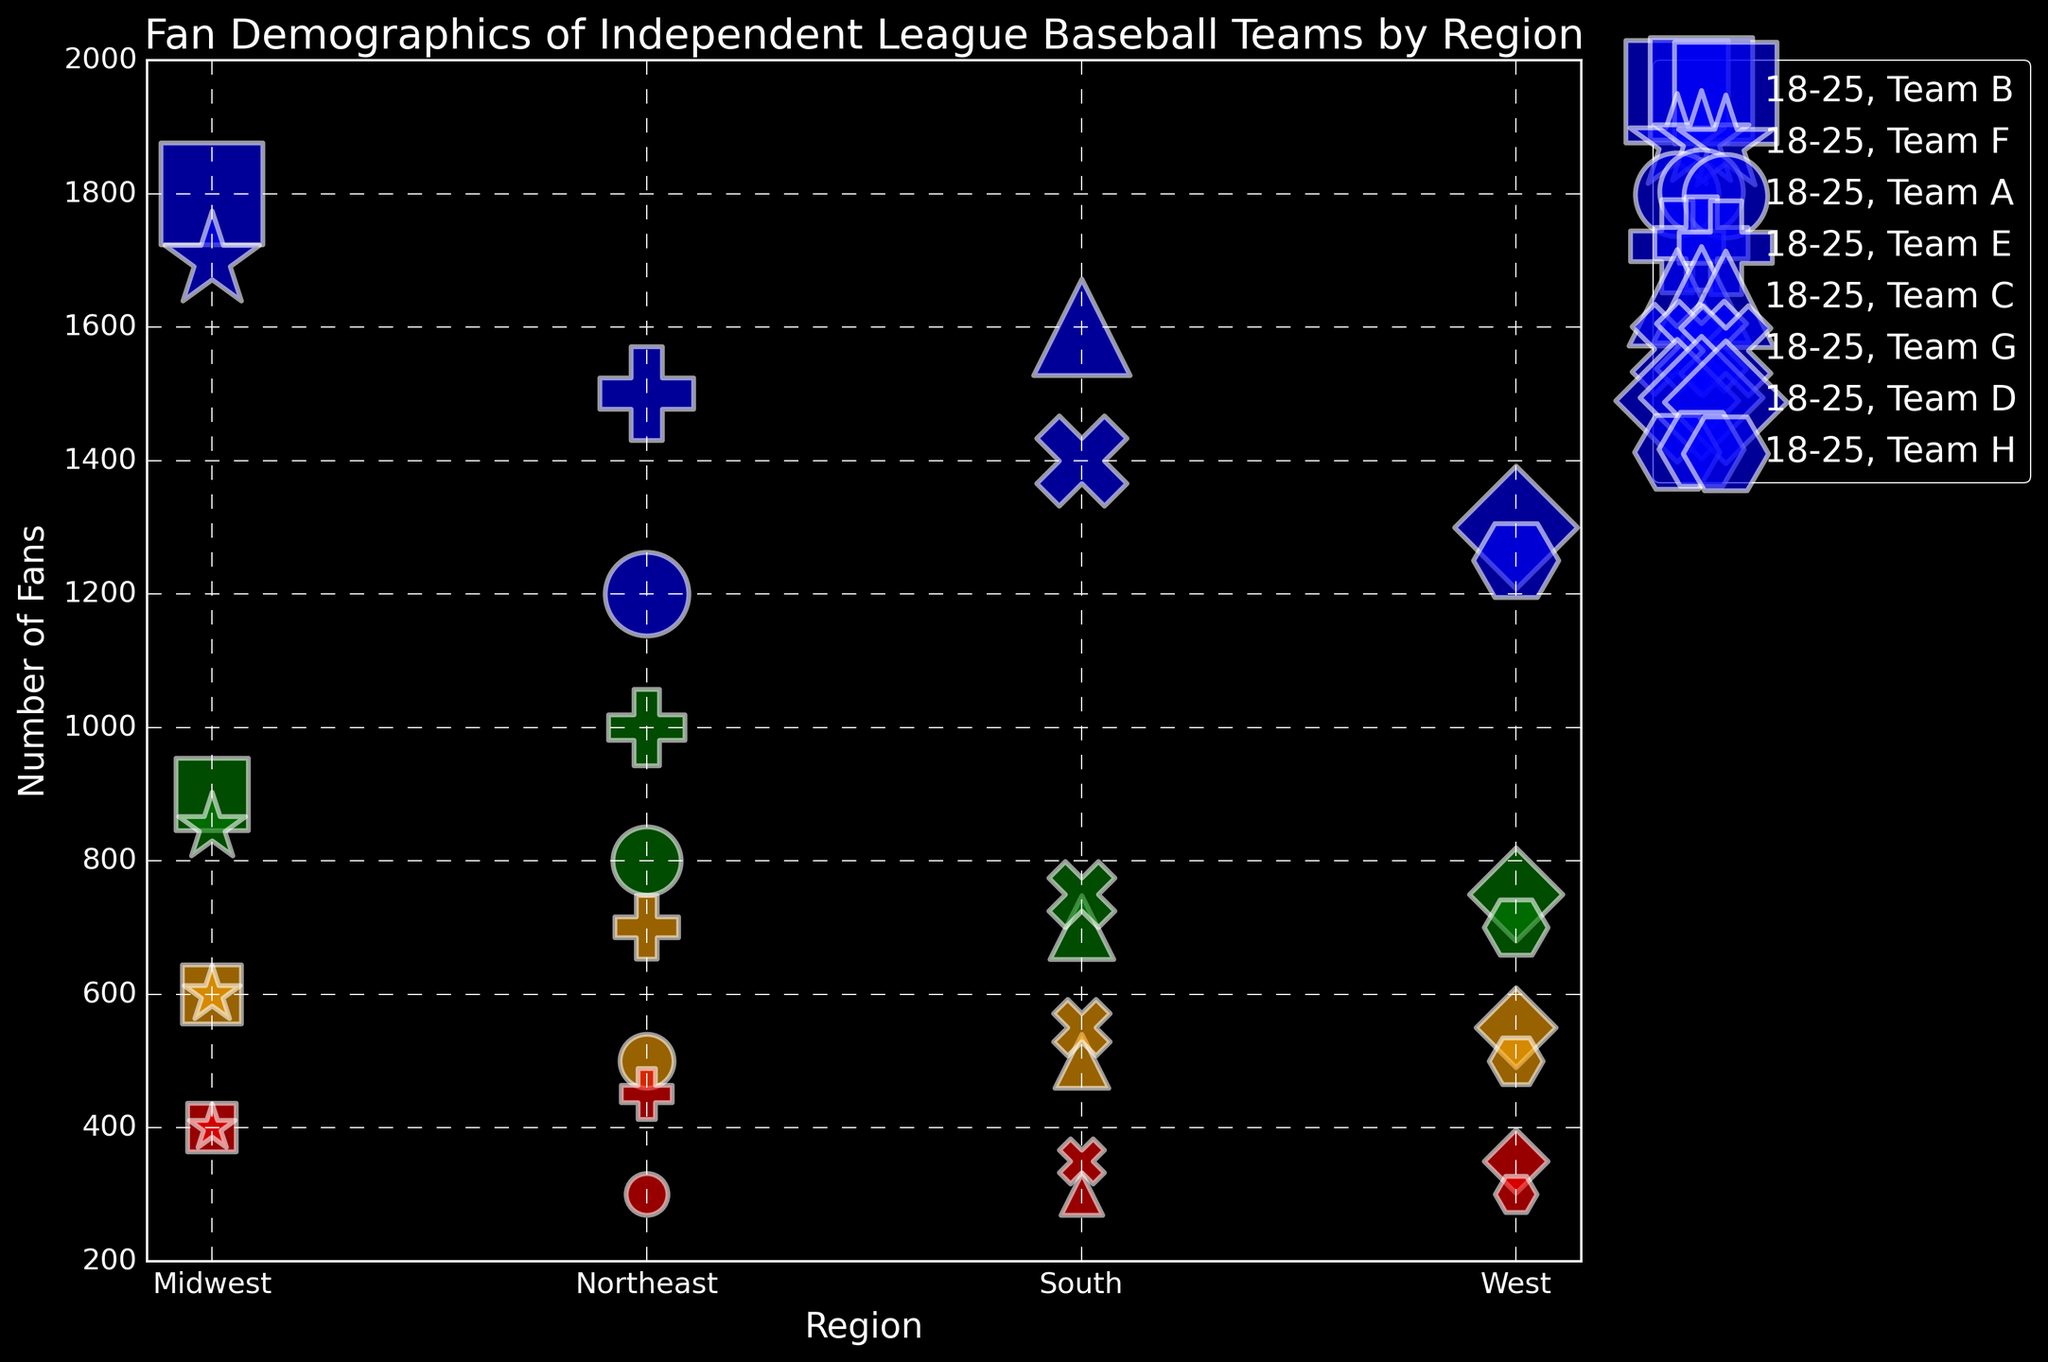What region has the most fans in the 18-25 age group? By observing the bubble sizes in each region, we can see that the largest blue bubble (indicating the 18-25 age group) is in the Midwest region. Therefore, the Midwest has the most fans in this age group.
Answer: Midwest Which team in the Northeast has more fans in the 26-35 age group, Team A or Team E? We should compare the green bubbles for Team A and Team E in the Northeast region. Team A has 800 fans in the 26-35 age group, while Team E has 1000 fans. Thus, Team E has more fans in this age group in the Northeast.
Answer: Team E What's the total number of fans for Team H across all age groups? Summing up the number of fans for Team H in each age group: 1250 (18-25) + 700 (26-35) + 500 (36-45) + 300 (46-60), we get a total of 2750 fans.
Answer: 2750 Which region has the smallest number of fans in the 46-60 age group? By observing the red bubbles (indicating the 46-60 age group) across all regions, we see that the Northeast and South both have the smallest bubbles of 300 fans each.
Answer: Northeast and South Which team has the largest fan base in the Midwest for the 18-25 age group? Looking at the blue bubbles in the Midwest region, Team B has 1800 fans, and Team F has 1700 fans. Thus, Team B has the largest fan base in the Midwest for this age group.
Answer: Team B How many more fans does Team C have in the 36-45 age group compared to the 46-60 age group? Team C has 500 fans in the 36-45 age group and 300 fans in the 46-60 age group. The difference is 500 - 300 = 200.
Answer: 200 What is the average number of fans for Team G across the 26-35 and 36-45 age groups? Sum the number of fans for Team G in the 26-35 and 36-45 age groups: 750 + 550 = 1300, then divide by the number of groups, which is 2. Thus, the average is 1300 / 2 = 650.
Answer: 650 Which region has the most teams with more than 1000 fans in the 18-25 age group? By examining the blue bubbles, the Northeast region has two teams (Team A and Team E) with more than 1000 fans each in the 18-25 age group. Therefore, the Northeast region has the most teams meeting this criterion.
Answer: Northeast 